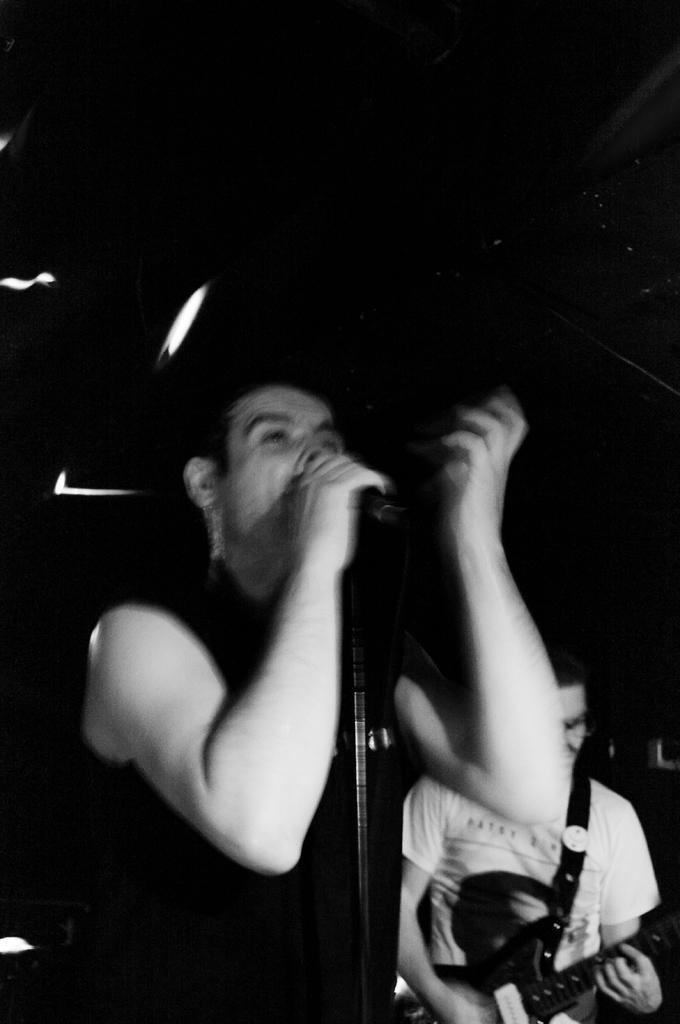How many people are in the image? There are two men in the image. What are the men holding in the image? One of the men is holding a microphone, and the other man is holding a guitar. What type of cake is being served in the image? There is no cake present in the image. What is the purpose of the wall in the image? There is no wall present in the image. 